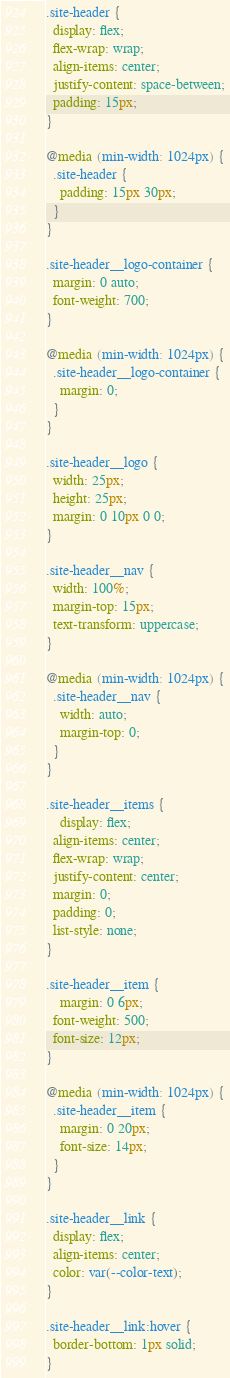Convert code to text. <code><loc_0><loc_0><loc_500><loc_500><_CSS_>.site-header {
  display: flex;
  flex-wrap: wrap;
  align-items: center;
  justify-content: space-between;
  padding: 15px;
}

@media (min-width: 1024px) {
  .site-header {
    padding: 15px 30px;
  }
}

.site-header__logo-container {
  margin: 0 auto;
  font-weight: 700;
}

@media (min-width: 1024px) {
  .site-header__logo-container {
    margin: 0;
  }
}

.site-header__logo {
  width: 25px;
  height: 25px;
  margin: 0 10px 0 0;
}

.site-header__nav {
  width: 100%;
  margin-top: 15px;
  text-transform: uppercase;
}

@media (min-width: 1024px) {
  .site-header__nav {
    width: auto;
    margin-top: 0;
  }
}

.site-header__items {
	display: flex;
  align-items: center;
  flex-wrap: wrap;
  justify-content: center;
  margin: 0;
  padding: 0;
  list-style: none;
}

.site-header__item {
	margin: 0 6px;
  font-weight: 500;
  font-size: 12px;
}

@media (min-width: 1024px) {
  .site-header__item {
    margin: 0 20px;
    font-size: 14px;
  }
}

.site-header__link {
  display: flex;
  align-items: center;
  color: var(--color-text);
}

.site-header__link:hover {
  border-bottom: 1px solid;
}

</code> 